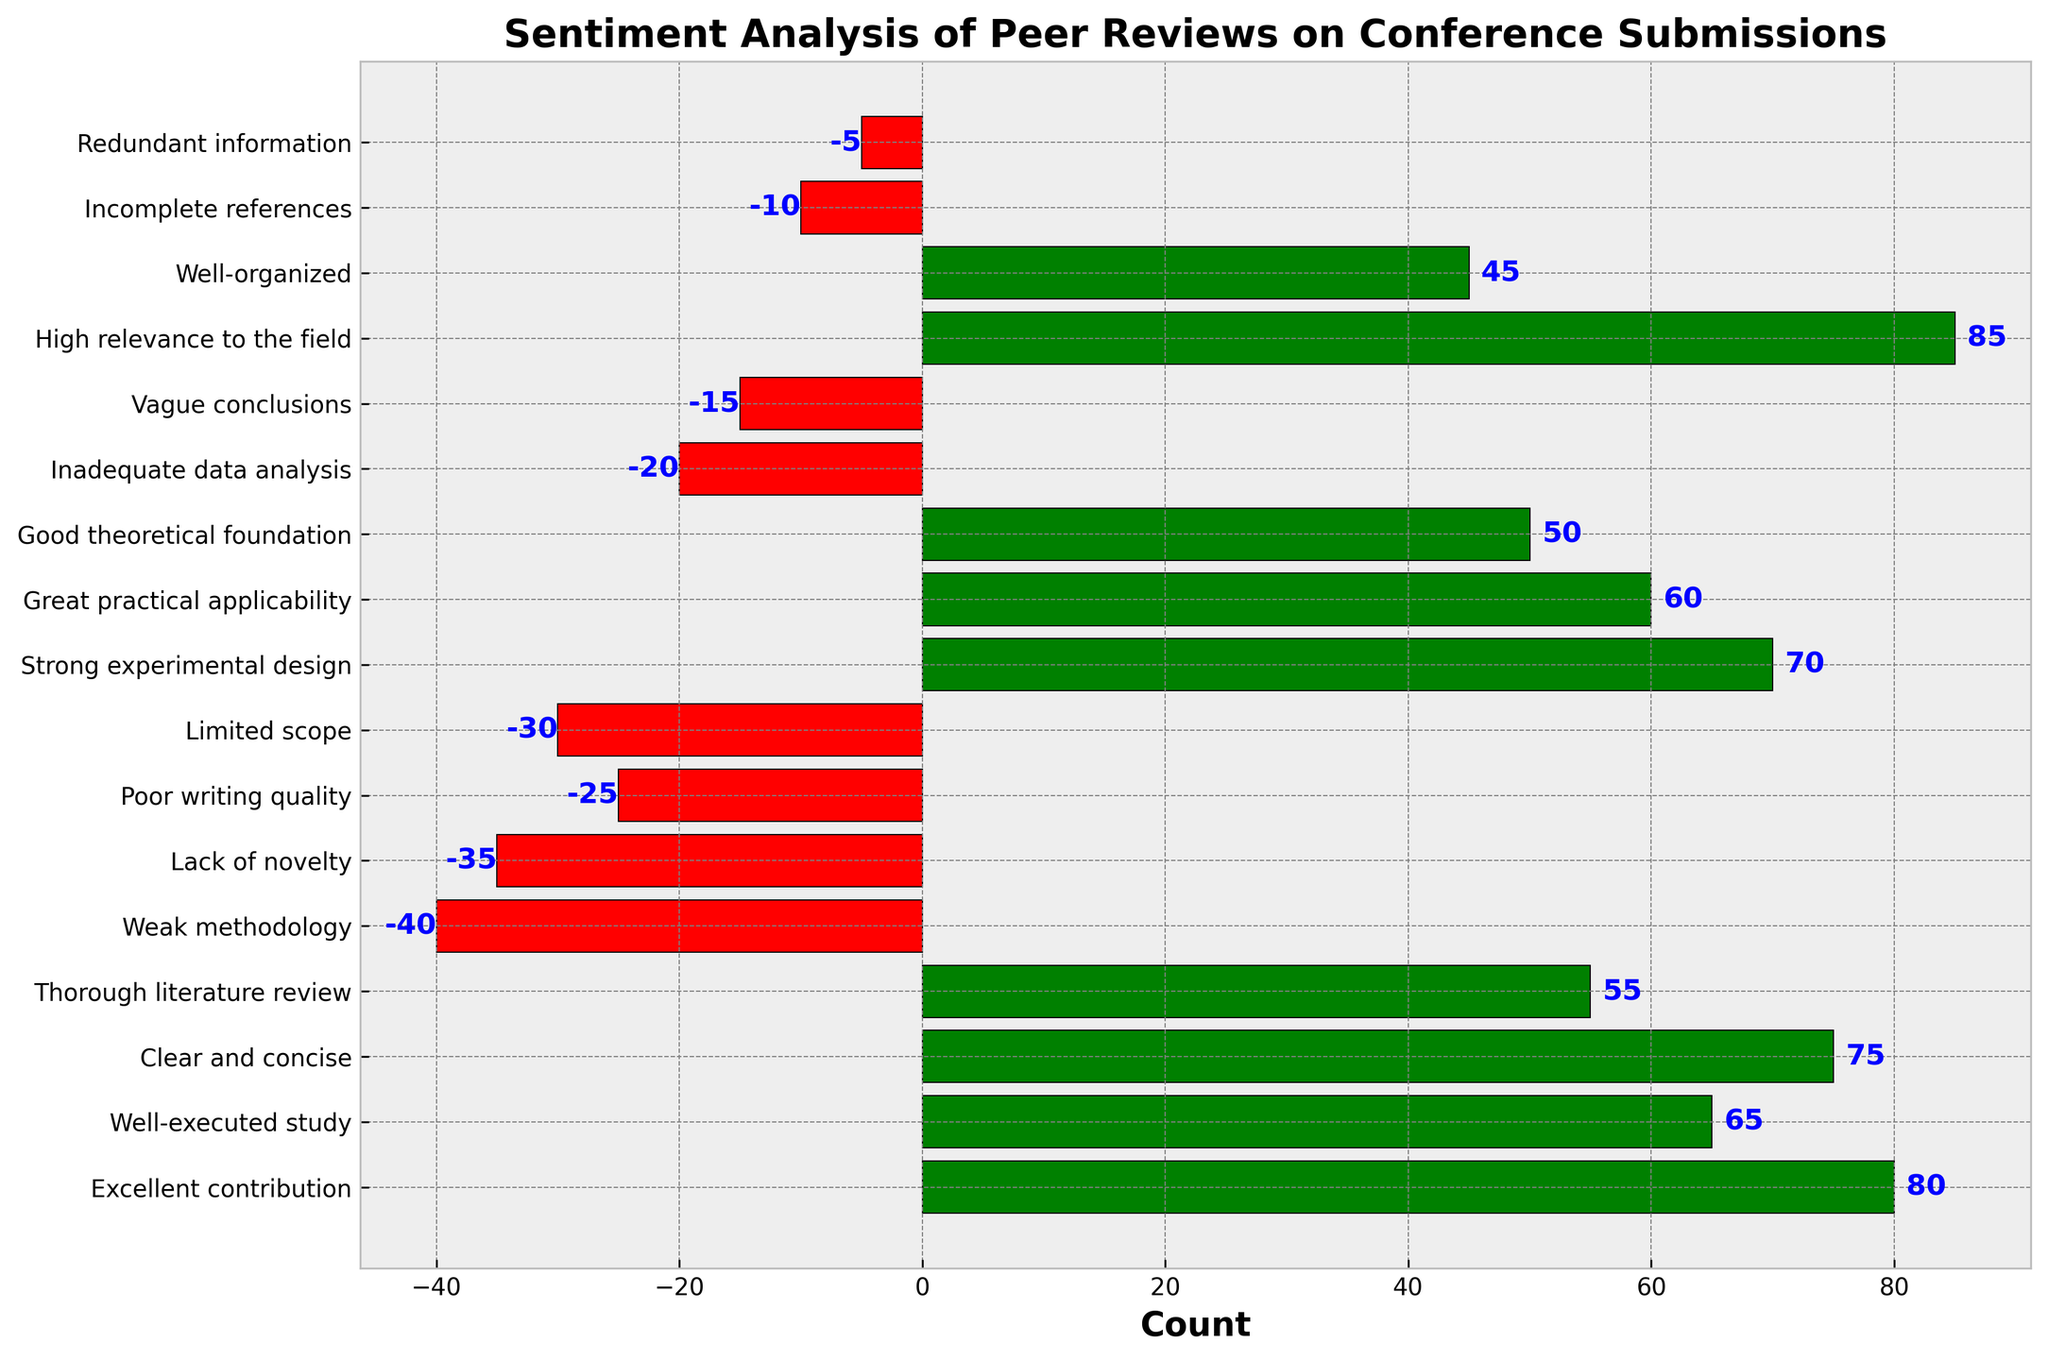What is the review with the highest count of positive feedback? The figure shows multiple reviews with positive and negative feedback counts. The tallest green bar indicates the highest count of positive feedback. The tallest green bar corresponds to "High relevance to the field" with a count of 85.
Answer: High relevance to the field Which feedback has the most negative sentiment? The figure shows multiple red bars representing negative sentiment. The longest red bar represents the highest count of negative feedback. The longest red bar corresponds to "Weak methodology" with a count of -40.
Answer: Weak methodology What is the difference between the count of "Excellent contribution" and "Lack of novelty"? Find the bars corresponding to "Excellent contribution" and "Lack of novelty". "Excellent contribution" has a count of 80 and "Lack of novelty" has a count of -35. Calculate the difference: 80 - (-35) = 115.
Answer: 115 Which feedback has a more substantial positive count: "Great practical applicability" or "Strong experimental design"? Locate the bars for "Great practical applicability" and "Strong experimental design". Compare the heights of the green bars. "Strong experimental design" has 70, and "Great practical applicability" has 60. Therefore, "Strong experimental design" has a higher count.
Answer: Strong experimental design What is the total positive sentiment count in the figure? Sum the counts of all the green bars representing positive sentiment. The counts are: 80, 65, 75, 55, 70, 60, 50, 85, and 45. The sum is 585.
Answer: 585 Which has a smaller count, "Inadequate data analysis" or "Vague conclusions"? Locate the bars for "Inadequate data analysis" with a count of -20 and "Vague conclusions" with a count of -15. Since -20 is smaller than -15, "Inadequate data analysis" has a smaller count.
Answer: Inadequate data analysis What is the approximate median of positive sentiment counts? Arrange the positive counts in ascending order: 45, 50, 55, 60, 65, 70, 75, 80, 85. The median is the middle value (5th value in a list of 9), which is 65.
Answer: 65 What is the average negative sentiment count? Sum the negative sentiment counts and divide by the number of negative sentiments: (-40) + (-35) + (-25) + (-30) + (-20) + (-15) + (-10) + (-5) = -180. There are 8 negative sentiments, so average = -180 / 8 = -22.5
Answer: -22.5 How much higher is the count of "Well-executed study" than "Poor writing quality"? Locate the bars for both reviews. "Well-executed study" has a count of 65, and "Poor writing quality" has a count of -25. The difference is 65 - (-25) = 90.
Answer: 90 What is the proportion of positive sentiment "Clear and concise" to the total positive sentiment count? "Clear and concise" has a positive count of 75. Total positive sentiment count is 585. Proportion = 75 / 585 ≈ 0.1282.
Answer: 0.1282 